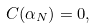<formula> <loc_0><loc_0><loc_500><loc_500>C ( \alpha _ { N } ) = 0 ,</formula> 